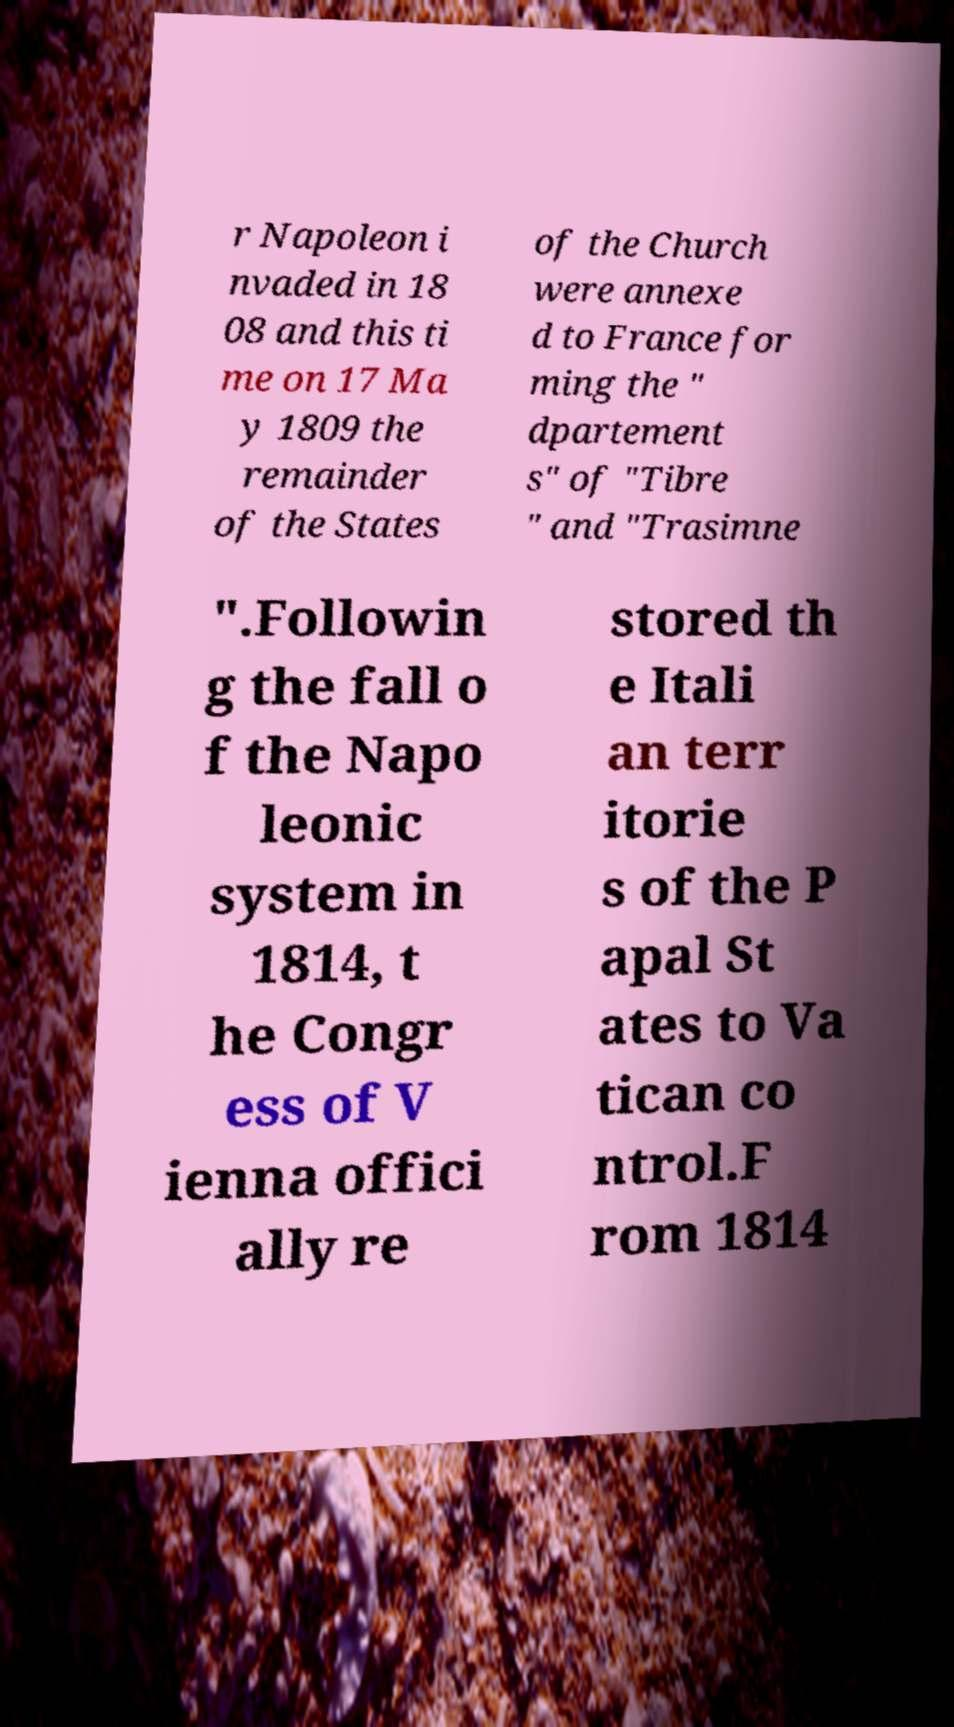Please read and relay the text visible in this image. What does it say? r Napoleon i nvaded in 18 08 and this ti me on 17 Ma y 1809 the remainder of the States of the Church were annexe d to France for ming the " dpartement s" of "Tibre " and "Trasimne ".Followin g the fall o f the Napo leonic system in 1814, t he Congr ess of V ienna offici ally re stored th e Itali an terr itorie s of the P apal St ates to Va tican co ntrol.F rom 1814 